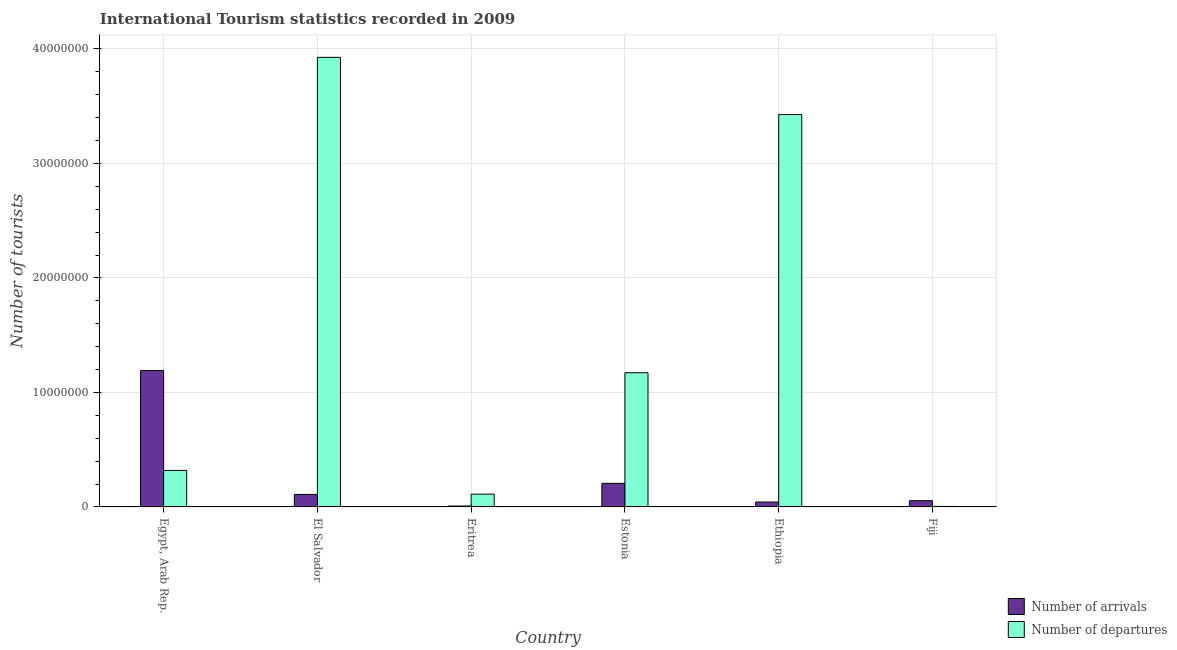Are the number of bars per tick equal to the number of legend labels?
Provide a short and direct response. Yes. How many bars are there on the 6th tick from the left?
Offer a terse response. 2. What is the label of the 4th group of bars from the left?
Your response must be concise. Estonia. What is the number of tourist departures in Eritrea?
Provide a short and direct response. 1.12e+06. Across all countries, what is the maximum number of tourist departures?
Provide a short and direct response. 3.93e+07. Across all countries, what is the minimum number of tourist departures?
Your answer should be compact. 4.40e+04. In which country was the number of tourist arrivals maximum?
Give a very brief answer. Egypt, Arab Rep. In which country was the number of tourist arrivals minimum?
Offer a terse response. Eritrea. What is the total number of tourist departures in the graph?
Your response must be concise. 8.96e+07. What is the difference between the number of tourist arrivals in Eritrea and that in Fiji?
Provide a short and direct response. -4.63e+05. What is the difference between the number of tourist departures in Ethiopia and the number of tourist arrivals in Egypt, Arab Rep.?
Provide a short and direct response. 2.24e+07. What is the average number of tourist departures per country?
Offer a terse response. 1.49e+07. What is the difference between the number of tourist arrivals and number of tourist departures in El Salvador?
Provide a short and direct response. -3.82e+07. In how many countries, is the number of tourist arrivals greater than 16000000 ?
Your response must be concise. 0. What is the ratio of the number of tourist departures in Eritrea to that in Estonia?
Offer a very short reply. 0.1. Is the number of tourist arrivals in Egypt, Arab Rep. less than that in Ethiopia?
Your response must be concise. No. What is the difference between the highest and the second highest number of tourist departures?
Give a very brief answer. 4.99e+06. What is the difference between the highest and the lowest number of tourist arrivals?
Your response must be concise. 1.18e+07. In how many countries, is the number of tourist departures greater than the average number of tourist departures taken over all countries?
Your response must be concise. 2. What does the 2nd bar from the left in Estonia represents?
Your response must be concise. Number of departures. What does the 1st bar from the right in Estonia represents?
Offer a terse response. Number of departures. How many bars are there?
Your answer should be compact. 12. Are all the bars in the graph horizontal?
Your response must be concise. No. How many countries are there in the graph?
Your answer should be compact. 6. Does the graph contain any zero values?
Give a very brief answer. No. What is the title of the graph?
Ensure brevity in your answer.  International Tourism statistics recorded in 2009. Does "Non-residents" appear as one of the legend labels in the graph?
Provide a succinct answer. No. What is the label or title of the X-axis?
Ensure brevity in your answer.  Country. What is the label or title of the Y-axis?
Offer a very short reply. Number of tourists. What is the Number of tourists in Number of arrivals in Egypt, Arab Rep.?
Provide a succinct answer. 1.19e+07. What is the Number of tourists of Number of departures in Egypt, Arab Rep.?
Offer a very short reply. 3.19e+06. What is the Number of tourists of Number of arrivals in El Salvador?
Your response must be concise. 1.09e+06. What is the Number of tourists of Number of departures in El Salvador?
Ensure brevity in your answer.  3.93e+07. What is the Number of tourists of Number of arrivals in Eritrea?
Offer a very short reply. 7.90e+04. What is the Number of tourists of Number of departures in Eritrea?
Make the answer very short. 1.12e+06. What is the Number of tourists of Number of arrivals in Estonia?
Offer a terse response. 2.06e+06. What is the Number of tourists of Number of departures in Estonia?
Offer a very short reply. 1.17e+07. What is the Number of tourists in Number of arrivals in Ethiopia?
Give a very brief answer. 4.27e+05. What is the Number of tourists in Number of departures in Ethiopia?
Keep it short and to the point. 3.43e+07. What is the Number of tourists of Number of arrivals in Fiji?
Your response must be concise. 5.42e+05. What is the Number of tourists in Number of departures in Fiji?
Provide a succinct answer. 4.40e+04. Across all countries, what is the maximum Number of tourists of Number of arrivals?
Make the answer very short. 1.19e+07. Across all countries, what is the maximum Number of tourists in Number of departures?
Keep it short and to the point. 3.93e+07. Across all countries, what is the minimum Number of tourists in Number of arrivals?
Your response must be concise. 7.90e+04. Across all countries, what is the minimum Number of tourists of Number of departures?
Your answer should be very brief. 4.40e+04. What is the total Number of tourists of Number of arrivals in the graph?
Offer a terse response. 1.61e+07. What is the total Number of tourists of Number of departures in the graph?
Offer a very short reply. 8.96e+07. What is the difference between the Number of tourists in Number of arrivals in Egypt, Arab Rep. and that in El Salvador?
Keep it short and to the point. 1.08e+07. What is the difference between the Number of tourists in Number of departures in Egypt, Arab Rep. and that in El Salvador?
Your response must be concise. -3.61e+07. What is the difference between the Number of tourists in Number of arrivals in Egypt, Arab Rep. and that in Eritrea?
Offer a terse response. 1.18e+07. What is the difference between the Number of tourists of Number of departures in Egypt, Arab Rep. and that in Eritrea?
Give a very brief answer. 2.07e+06. What is the difference between the Number of tourists of Number of arrivals in Egypt, Arab Rep. and that in Estonia?
Offer a very short reply. 9.86e+06. What is the difference between the Number of tourists in Number of departures in Egypt, Arab Rep. and that in Estonia?
Offer a terse response. -8.54e+06. What is the difference between the Number of tourists in Number of arrivals in Egypt, Arab Rep. and that in Ethiopia?
Your answer should be compact. 1.15e+07. What is the difference between the Number of tourists in Number of departures in Egypt, Arab Rep. and that in Ethiopia?
Provide a succinct answer. -3.11e+07. What is the difference between the Number of tourists of Number of arrivals in Egypt, Arab Rep. and that in Fiji?
Offer a very short reply. 1.14e+07. What is the difference between the Number of tourists of Number of departures in Egypt, Arab Rep. and that in Fiji?
Offer a very short reply. 3.14e+06. What is the difference between the Number of tourists in Number of arrivals in El Salvador and that in Eritrea?
Offer a terse response. 1.01e+06. What is the difference between the Number of tourists of Number of departures in El Salvador and that in Eritrea?
Your answer should be compact. 3.82e+07. What is the difference between the Number of tourists of Number of arrivals in El Salvador and that in Estonia?
Your response must be concise. -9.68e+05. What is the difference between the Number of tourists in Number of departures in El Salvador and that in Estonia?
Give a very brief answer. 2.75e+07. What is the difference between the Number of tourists in Number of arrivals in El Salvador and that in Ethiopia?
Make the answer very short. 6.64e+05. What is the difference between the Number of tourists of Number of departures in El Salvador and that in Ethiopia?
Ensure brevity in your answer.  4.99e+06. What is the difference between the Number of tourists in Number of arrivals in El Salvador and that in Fiji?
Ensure brevity in your answer.  5.49e+05. What is the difference between the Number of tourists of Number of departures in El Salvador and that in Fiji?
Provide a short and direct response. 3.92e+07. What is the difference between the Number of tourists in Number of arrivals in Eritrea and that in Estonia?
Your answer should be very brief. -1.98e+06. What is the difference between the Number of tourists of Number of departures in Eritrea and that in Estonia?
Ensure brevity in your answer.  -1.06e+07. What is the difference between the Number of tourists of Number of arrivals in Eritrea and that in Ethiopia?
Ensure brevity in your answer.  -3.48e+05. What is the difference between the Number of tourists in Number of departures in Eritrea and that in Ethiopia?
Provide a short and direct response. -3.32e+07. What is the difference between the Number of tourists in Number of arrivals in Eritrea and that in Fiji?
Give a very brief answer. -4.63e+05. What is the difference between the Number of tourists in Number of departures in Eritrea and that in Fiji?
Your response must be concise. 1.07e+06. What is the difference between the Number of tourists in Number of arrivals in Estonia and that in Ethiopia?
Your answer should be compact. 1.63e+06. What is the difference between the Number of tourists in Number of departures in Estonia and that in Ethiopia?
Your answer should be very brief. -2.26e+07. What is the difference between the Number of tourists in Number of arrivals in Estonia and that in Fiji?
Keep it short and to the point. 1.52e+06. What is the difference between the Number of tourists of Number of departures in Estonia and that in Fiji?
Your response must be concise. 1.17e+07. What is the difference between the Number of tourists in Number of arrivals in Ethiopia and that in Fiji?
Offer a very short reply. -1.15e+05. What is the difference between the Number of tourists in Number of departures in Ethiopia and that in Fiji?
Provide a succinct answer. 3.42e+07. What is the difference between the Number of tourists of Number of arrivals in Egypt, Arab Rep. and the Number of tourists of Number of departures in El Salvador?
Provide a succinct answer. -2.74e+07. What is the difference between the Number of tourists of Number of arrivals in Egypt, Arab Rep. and the Number of tourists of Number of departures in Eritrea?
Make the answer very short. 1.08e+07. What is the difference between the Number of tourists of Number of arrivals in Egypt, Arab Rep. and the Number of tourists of Number of departures in Estonia?
Offer a terse response. 1.91e+05. What is the difference between the Number of tourists in Number of arrivals in Egypt, Arab Rep. and the Number of tourists in Number of departures in Ethiopia?
Ensure brevity in your answer.  -2.24e+07. What is the difference between the Number of tourists of Number of arrivals in Egypt, Arab Rep. and the Number of tourists of Number of departures in Fiji?
Give a very brief answer. 1.19e+07. What is the difference between the Number of tourists of Number of arrivals in El Salvador and the Number of tourists of Number of departures in Eritrea?
Make the answer very short. -2.50e+04. What is the difference between the Number of tourists of Number of arrivals in El Salvador and the Number of tourists of Number of departures in Estonia?
Make the answer very short. -1.06e+07. What is the difference between the Number of tourists in Number of arrivals in El Salvador and the Number of tourists in Number of departures in Ethiopia?
Make the answer very short. -3.32e+07. What is the difference between the Number of tourists of Number of arrivals in El Salvador and the Number of tourists of Number of departures in Fiji?
Provide a succinct answer. 1.05e+06. What is the difference between the Number of tourists of Number of arrivals in Eritrea and the Number of tourists of Number of departures in Estonia?
Make the answer very short. -1.16e+07. What is the difference between the Number of tourists in Number of arrivals in Eritrea and the Number of tourists in Number of departures in Ethiopia?
Your answer should be compact. -3.42e+07. What is the difference between the Number of tourists in Number of arrivals in Eritrea and the Number of tourists in Number of departures in Fiji?
Make the answer very short. 3.50e+04. What is the difference between the Number of tourists of Number of arrivals in Estonia and the Number of tourists of Number of departures in Ethiopia?
Give a very brief answer. -3.22e+07. What is the difference between the Number of tourists of Number of arrivals in Estonia and the Number of tourists of Number of departures in Fiji?
Your answer should be compact. 2.02e+06. What is the difference between the Number of tourists of Number of arrivals in Ethiopia and the Number of tourists of Number of departures in Fiji?
Your response must be concise. 3.83e+05. What is the average Number of tourists of Number of arrivals per country?
Your answer should be compact. 2.69e+06. What is the average Number of tourists of Number of departures per country?
Keep it short and to the point. 1.49e+07. What is the difference between the Number of tourists of Number of arrivals and Number of tourists of Number of departures in Egypt, Arab Rep.?
Give a very brief answer. 8.73e+06. What is the difference between the Number of tourists of Number of arrivals and Number of tourists of Number of departures in El Salvador?
Your answer should be compact. -3.82e+07. What is the difference between the Number of tourists of Number of arrivals and Number of tourists of Number of departures in Eritrea?
Ensure brevity in your answer.  -1.04e+06. What is the difference between the Number of tourists in Number of arrivals and Number of tourists in Number of departures in Estonia?
Your answer should be very brief. -9.66e+06. What is the difference between the Number of tourists in Number of arrivals and Number of tourists in Number of departures in Ethiopia?
Give a very brief answer. -3.38e+07. What is the difference between the Number of tourists in Number of arrivals and Number of tourists in Number of departures in Fiji?
Your response must be concise. 4.98e+05. What is the ratio of the Number of tourists of Number of arrivals in Egypt, Arab Rep. to that in El Salvador?
Offer a terse response. 10.92. What is the ratio of the Number of tourists in Number of departures in Egypt, Arab Rep. to that in El Salvador?
Provide a succinct answer. 0.08. What is the ratio of the Number of tourists in Number of arrivals in Egypt, Arab Rep. to that in Eritrea?
Provide a short and direct response. 150.81. What is the ratio of the Number of tourists in Number of departures in Egypt, Arab Rep. to that in Eritrea?
Your response must be concise. 2.86. What is the ratio of the Number of tourists of Number of arrivals in Egypt, Arab Rep. to that in Estonia?
Provide a succinct answer. 5.79. What is the ratio of the Number of tourists of Number of departures in Egypt, Arab Rep. to that in Estonia?
Your response must be concise. 0.27. What is the ratio of the Number of tourists in Number of arrivals in Egypt, Arab Rep. to that in Ethiopia?
Your answer should be compact. 27.9. What is the ratio of the Number of tourists in Number of departures in Egypt, Arab Rep. to that in Ethiopia?
Give a very brief answer. 0.09. What is the ratio of the Number of tourists in Number of arrivals in Egypt, Arab Rep. to that in Fiji?
Provide a short and direct response. 21.98. What is the ratio of the Number of tourists in Number of departures in Egypt, Arab Rep. to that in Fiji?
Ensure brevity in your answer.  72.45. What is the ratio of the Number of tourists of Number of arrivals in El Salvador to that in Eritrea?
Your response must be concise. 13.81. What is the ratio of the Number of tourists of Number of departures in El Salvador to that in Eritrea?
Offer a terse response. 35.19. What is the ratio of the Number of tourists in Number of arrivals in El Salvador to that in Estonia?
Your answer should be compact. 0.53. What is the ratio of the Number of tourists of Number of departures in El Salvador to that in Estonia?
Give a very brief answer. 3.35. What is the ratio of the Number of tourists in Number of arrivals in El Salvador to that in Ethiopia?
Your answer should be compact. 2.56. What is the ratio of the Number of tourists of Number of departures in El Salvador to that in Ethiopia?
Provide a succinct answer. 1.15. What is the ratio of the Number of tourists in Number of arrivals in El Salvador to that in Fiji?
Keep it short and to the point. 2.01. What is the ratio of the Number of tourists of Number of departures in El Salvador to that in Fiji?
Give a very brief answer. 892.5. What is the ratio of the Number of tourists in Number of arrivals in Eritrea to that in Estonia?
Ensure brevity in your answer.  0.04. What is the ratio of the Number of tourists of Number of departures in Eritrea to that in Estonia?
Give a very brief answer. 0.1. What is the ratio of the Number of tourists of Number of arrivals in Eritrea to that in Ethiopia?
Make the answer very short. 0.18. What is the ratio of the Number of tourists in Number of departures in Eritrea to that in Ethiopia?
Offer a terse response. 0.03. What is the ratio of the Number of tourists in Number of arrivals in Eritrea to that in Fiji?
Your answer should be compact. 0.15. What is the ratio of the Number of tourists in Number of departures in Eritrea to that in Fiji?
Your answer should be very brief. 25.36. What is the ratio of the Number of tourists of Number of arrivals in Estonia to that in Ethiopia?
Keep it short and to the point. 4.82. What is the ratio of the Number of tourists in Number of departures in Estonia to that in Ethiopia?
Provide a succinct answer. 0.34. What is the ratio of the Number of tourists in Number of arrivals in Estonia to that in Fiji?
Offer a terse response. 3.8. What is the ratio of the Number of tourists of Number of departures in Estonia to that in Fiji?
Ensure brevity in your answer.  266.43. What is the ratio of the Number of tourists of Number of arrivals in Ethiopia to that in Fiji?
Give a very brief answer. 0.79. What is the ratio of the Number of tourists of Number of departures in Ethiopia to that in Fiji?
Ensure brevity in your answer.  779. What is the difference between the highest and the second highest Number of tourists of Number of arrivals?
Your response must be concise. 9.86e+06. What is the difference between the highest and the second highest Number of tourists of Number of departures?
Make the answer very short. 4.99e+06. What is the difference between the highest and the lowest Number of tourists of Number of arrivals?
Your response must be concise. 1.18e+07. What is the difference between the highest and the lowest Number of tourists of Number of departures?
Ensure brevity in your answer.  3.92e+07. 